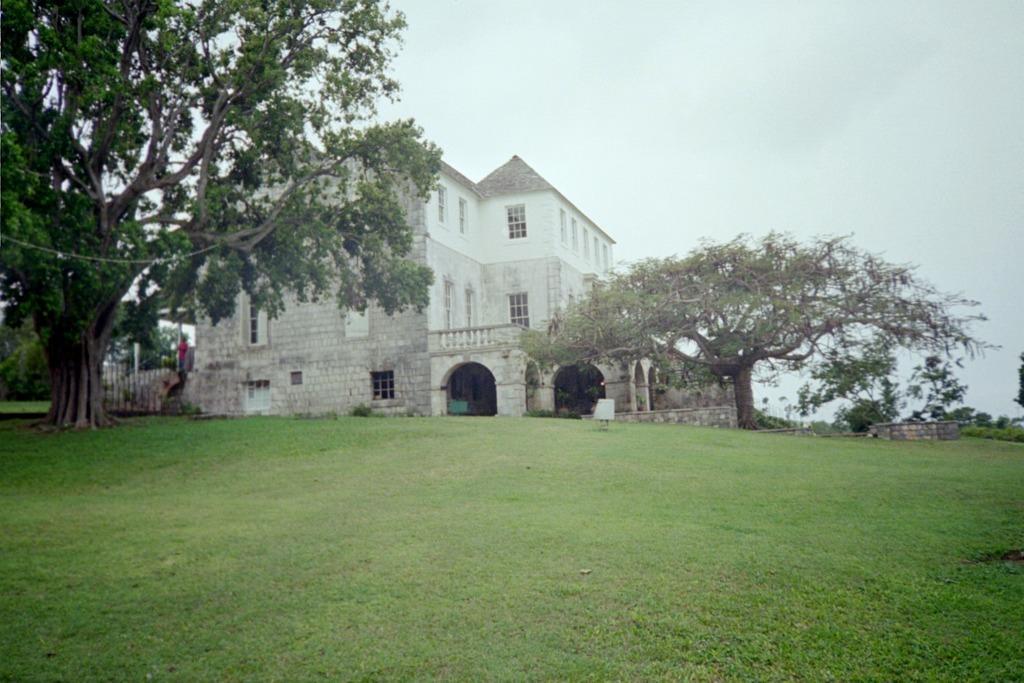How would you summarize this image in a sentence or two? In the image we can see there is a ground covered with grass and there are trees at the back. Behind there is a building and there is a person standing on the stairs. There is a clear sky. 